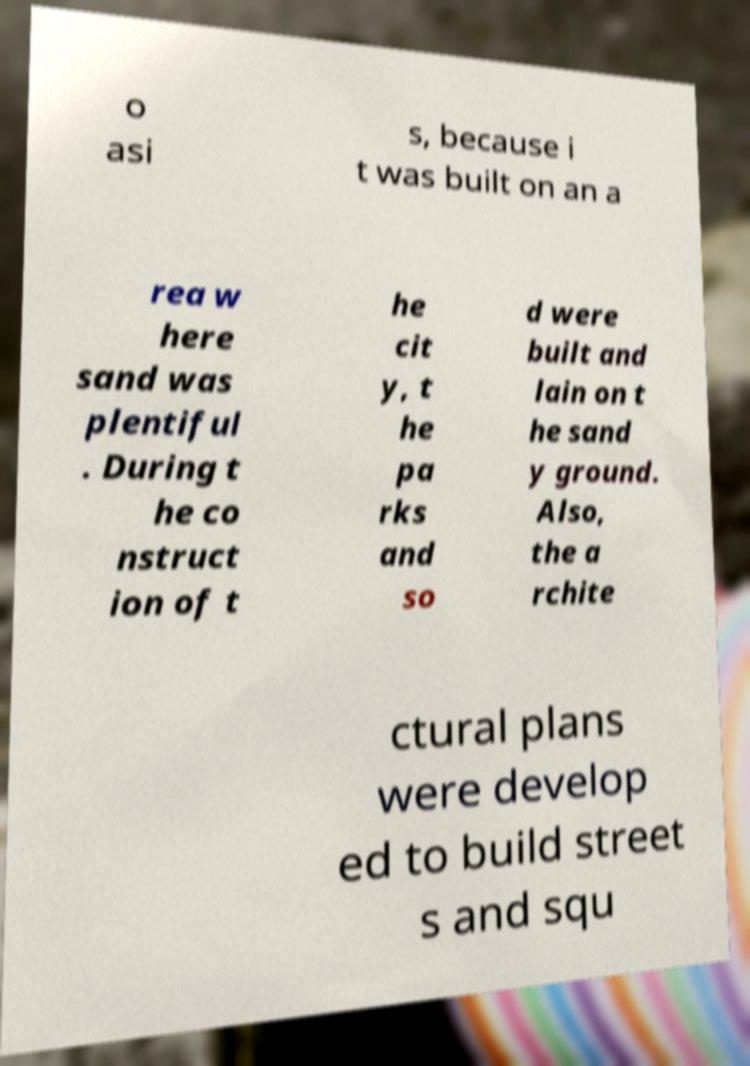There's text embedded in this image that I need extracted. Can you transcribe it verbatim? o asi s, because i t was built on an a rea w here sand was plentiful . During t he co nstruct ion of t he cit y, t he pa rks and so d were built and lain on t he sand y ground. Also, the a rchite ctural plans were develop ed to build street s and squ 